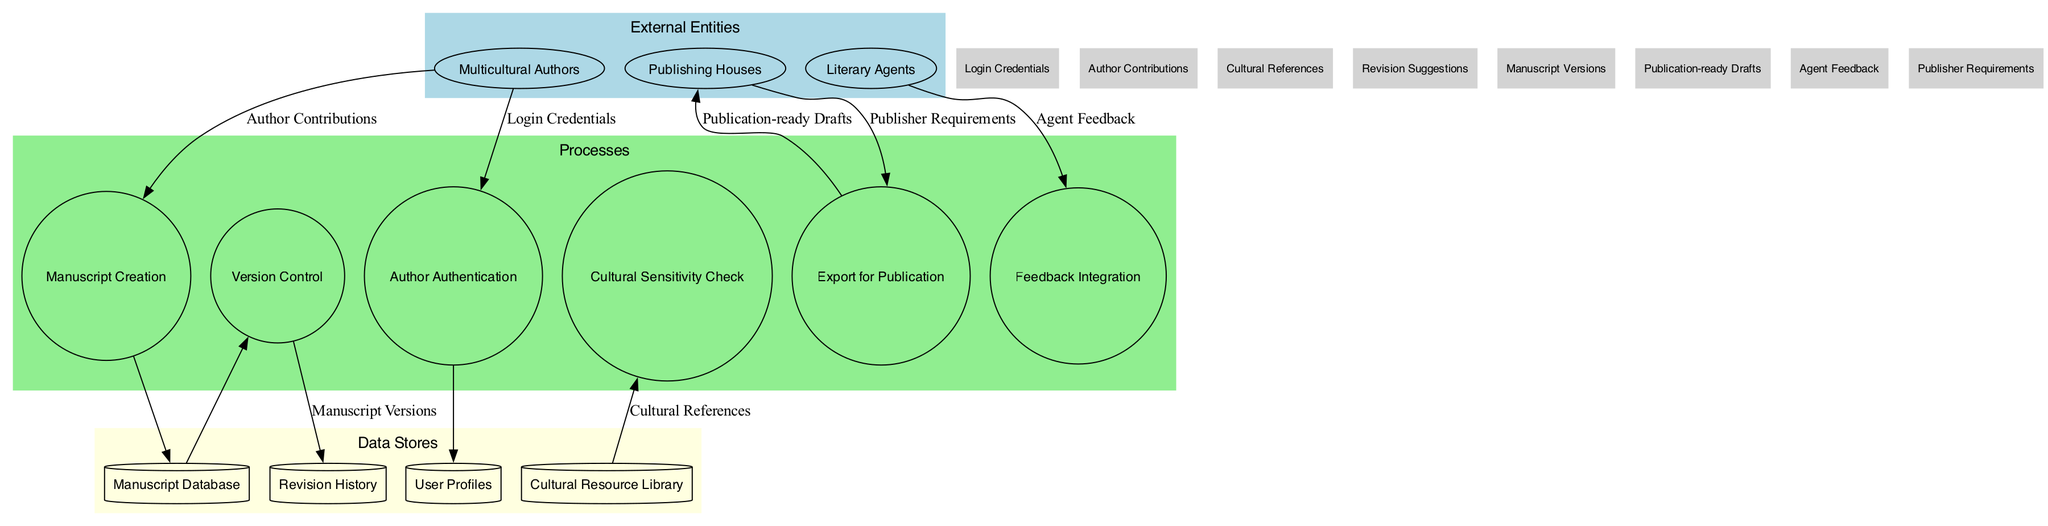What are the external entities in the diagram? The external entities are listed under the "External Entities" section, represented as ellipses. They include "Multicultural Authors," "Publishing Houses," and "Literary Agents."
Answer: Multicultural Authors, Publishing Houses, Literary Agents How many processes are represented in the diagram? The number of processes can be counted in the "Processes" cluster. There are six processes: "Author Authentication," "Manuscript Creation," "Cultural Sensitivity Check," "Version Control," "Feedback Integration," and "Export for Publication."
Answer: 6 What data flow connects "Multicultural Authors" to "Manuscript Creation"? The specific data flow connecting "Multicultural Authors" to "Manuscript Creation" is identified on the arrow between these two nodes, labeled as "Author Contributions."
Answer: Author Contributions Which data store is associated with "Version Control"? The connection from "Version Control" leads to "Revision History," indicating that it interacts with this specific data store. This is noted in the edge connecting them.
Answer: Revision History What feedback does "Literary Agents" provide in the process? The arrow from "Literary Agents" to "Feedback Integration" shows that the feedback communicated is labeled as "Agent Feedback." This indicates what type of input is being given to the process.
Answer: Agent Feedback In which order do the processes take place after "Manuscript Creation"? Following "Manuscript Creation," the flow moves to "Manuscript Database" and then proceeds to the "Cultural Sensitivity Check," before going to "Version Control." This sequence creates a pathway that illustrates the order of processes clearly.
Answer: Manuscript Database, Cultural Sensitivity Check, Version Control What is exported for publication? The diagram indicates that a "Publication-ready Drafts" is the output from the "Export for Publication" process, which signifies what is actually being exported at this stage.
Answer: Publication-ready Drafts How many data stores are in the diagram? The total can be counted from the "Data Stores" section, which contains four elements: "User Profiles," "Manuscript Database," "Cultural Resource Library," and "Revision History."
Answer: 4 